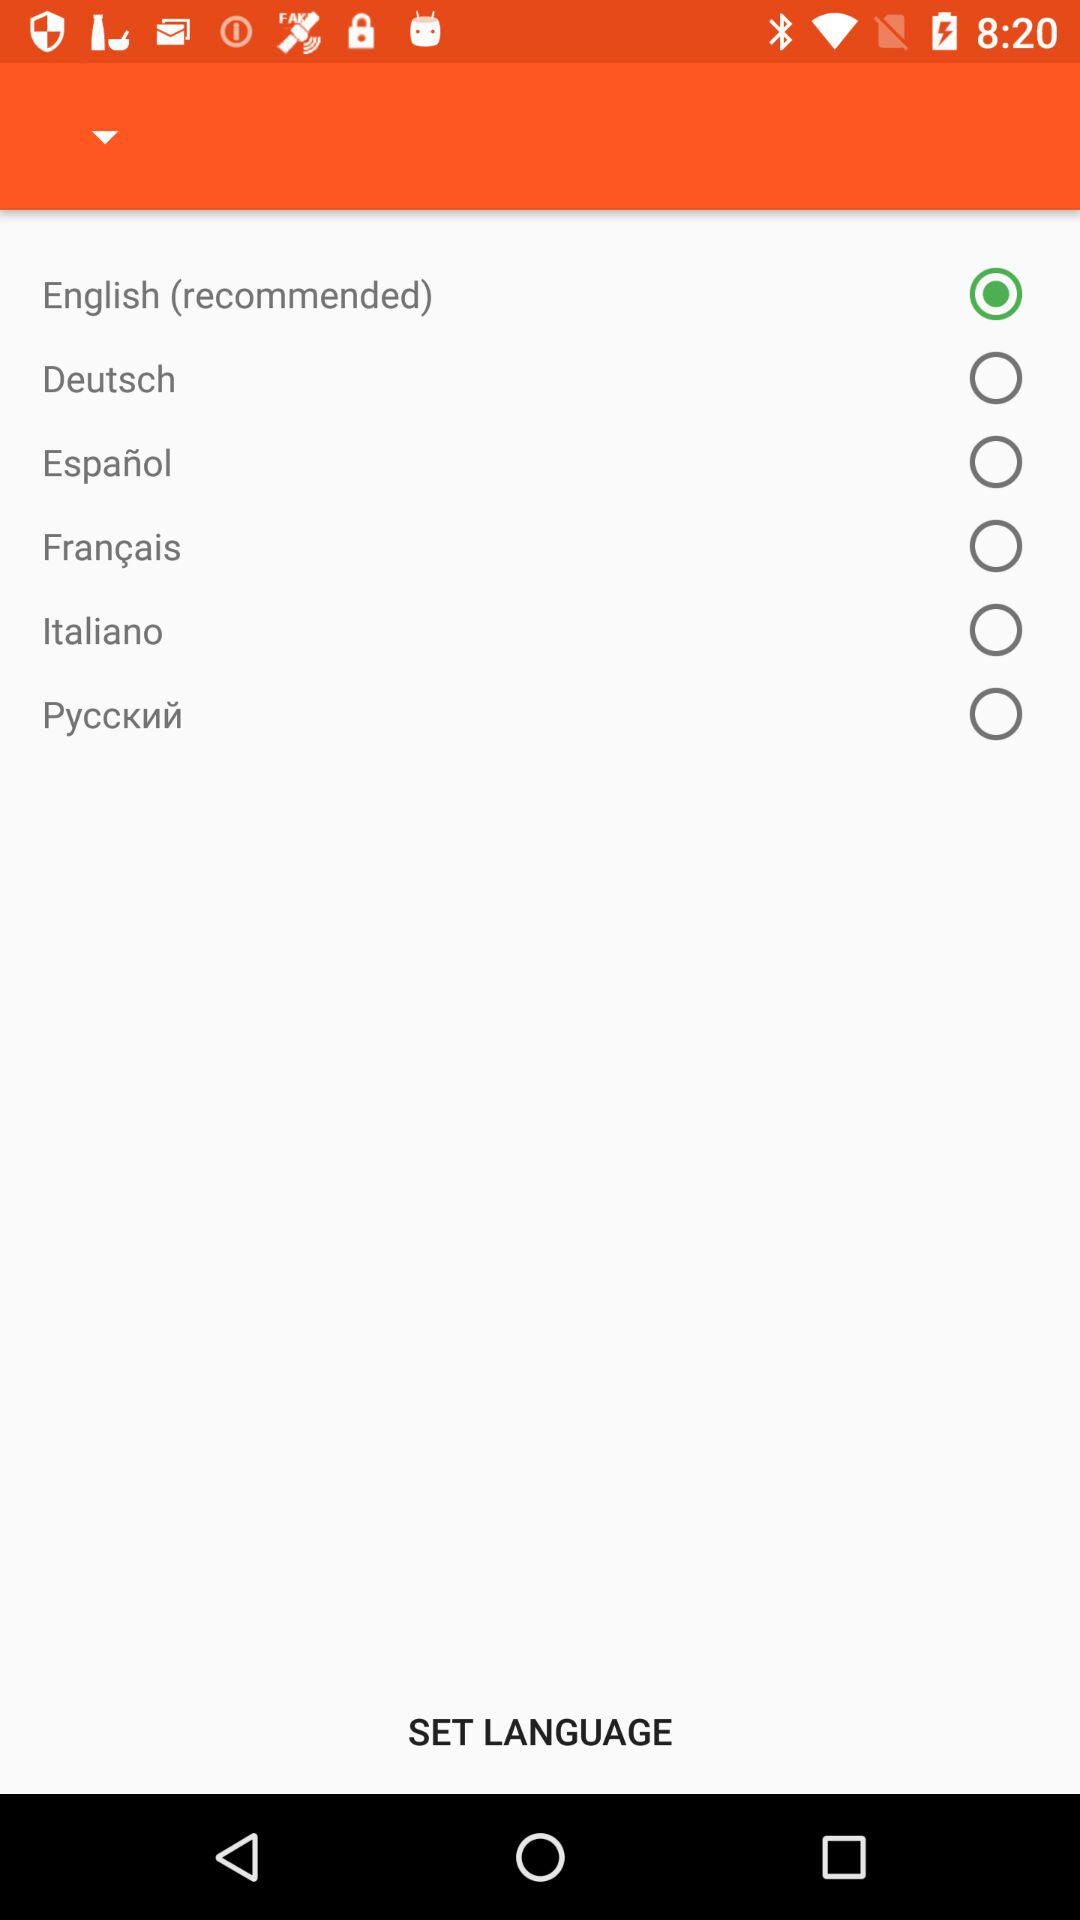How many languages are available to choose from?
Answer the question using a single word or phrase. 6 